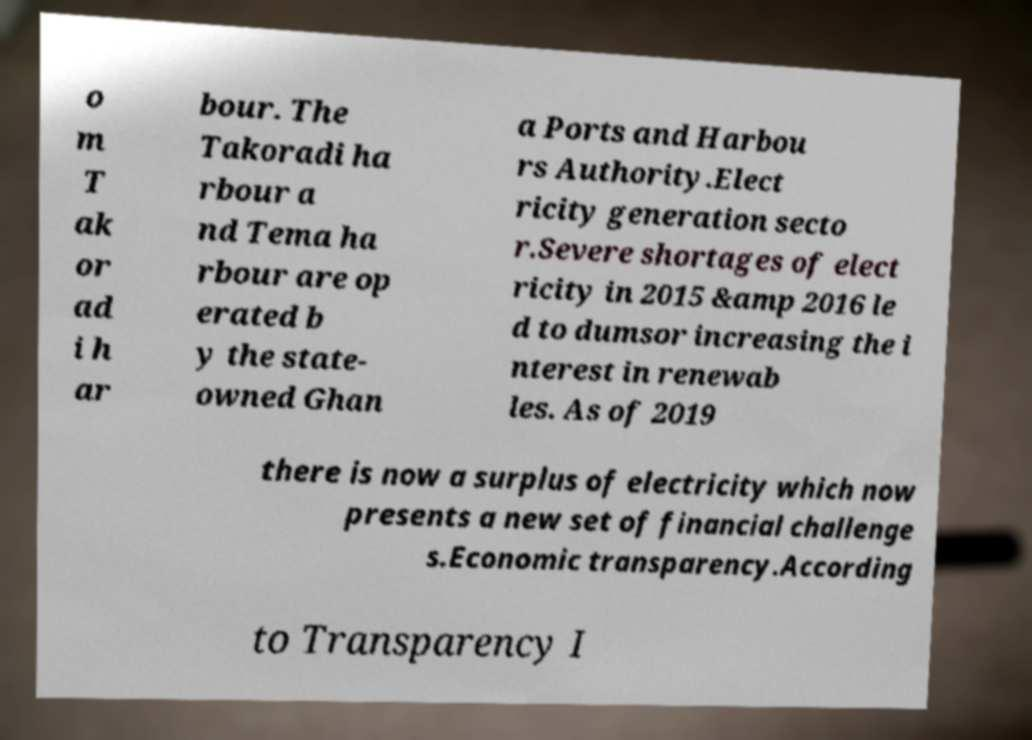Could you assist in decoding the text presented in this image and type it out clearly? o m T ak or ad i h ar bour. The Takoradi ha rbour a nd Tema ha rbour are op erated b y the state- owned Ghan a Ports and Harbou rs Authority.Elect ricity generation secto r.Severe shortages of elect ricity in 2015 &amp 2016 le d to dumsor increasing the i nterest in renewab les. As of 2019 there is now a surplus of electricity which now presents a new set of financial challenge s.Economic transparency.According to Transparency I 